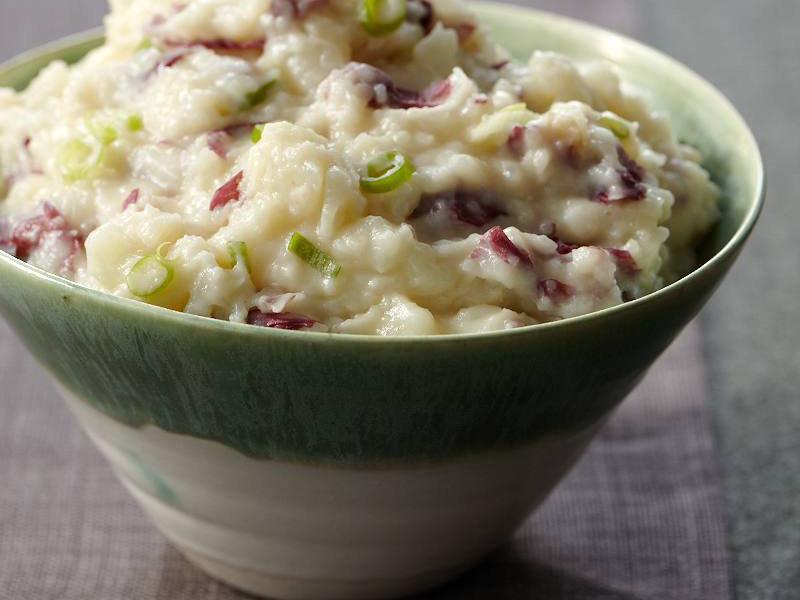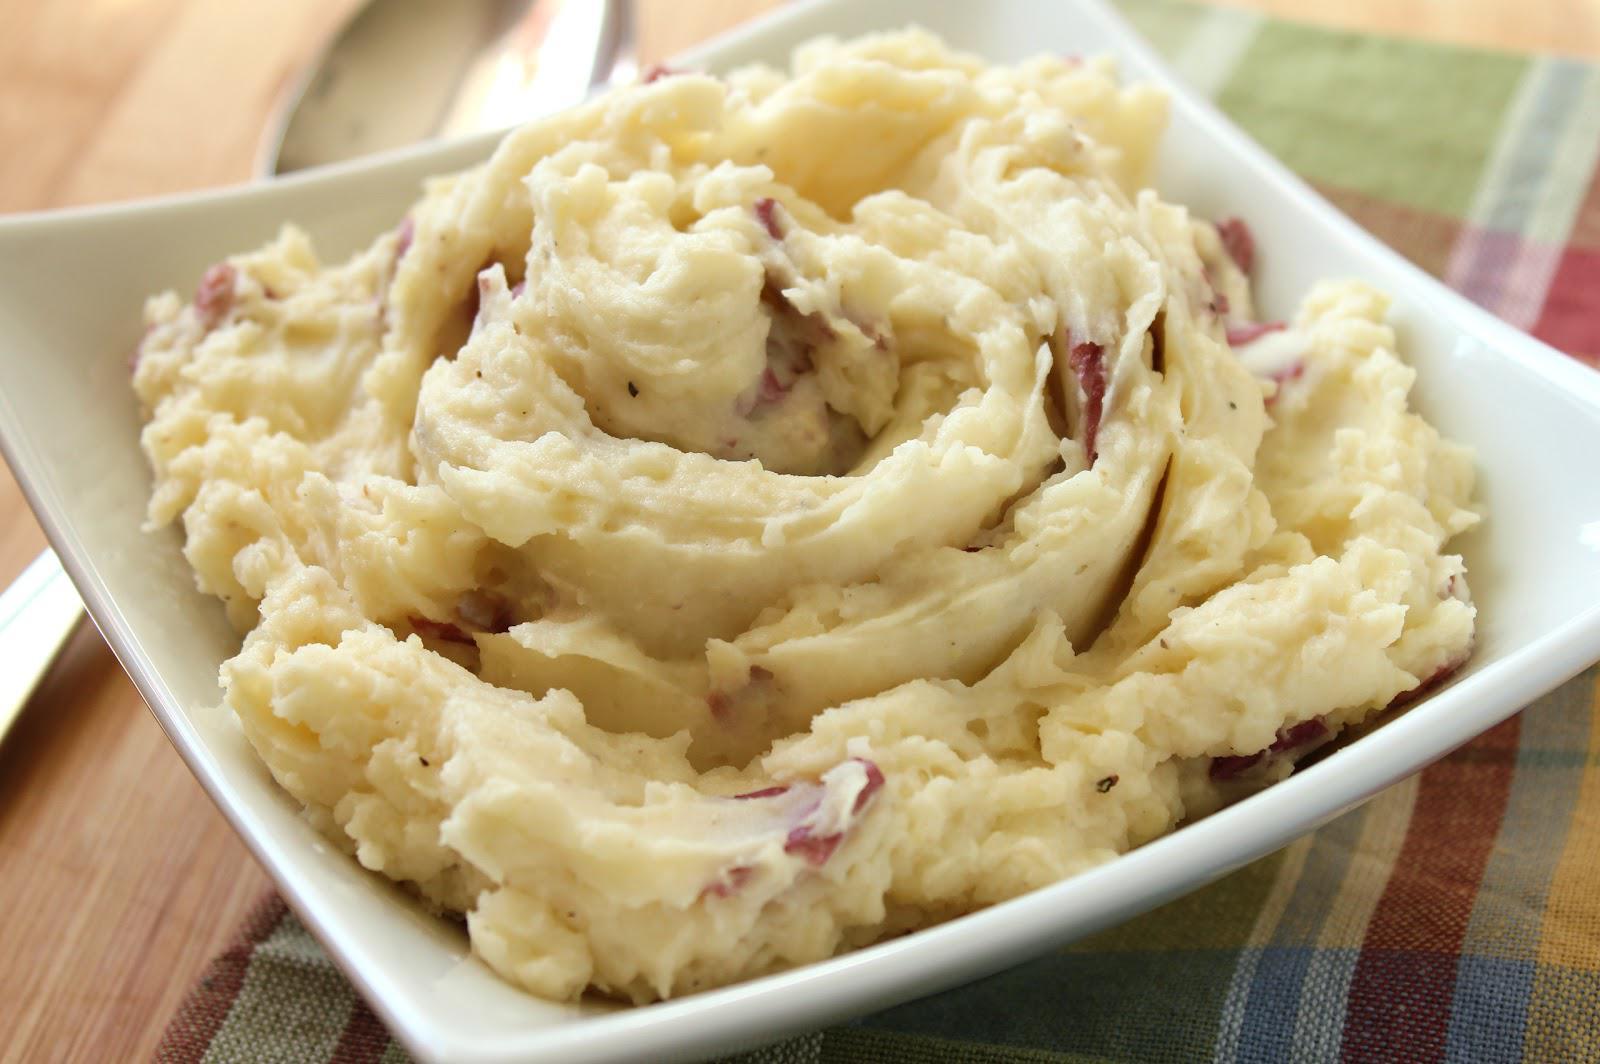The first image is the image on the left, the second image is the image on the right. Examine the images to the left and right. Is the description "There is one spoon sitting next to a bowl of food." accurate? Answer yes or no. No. 